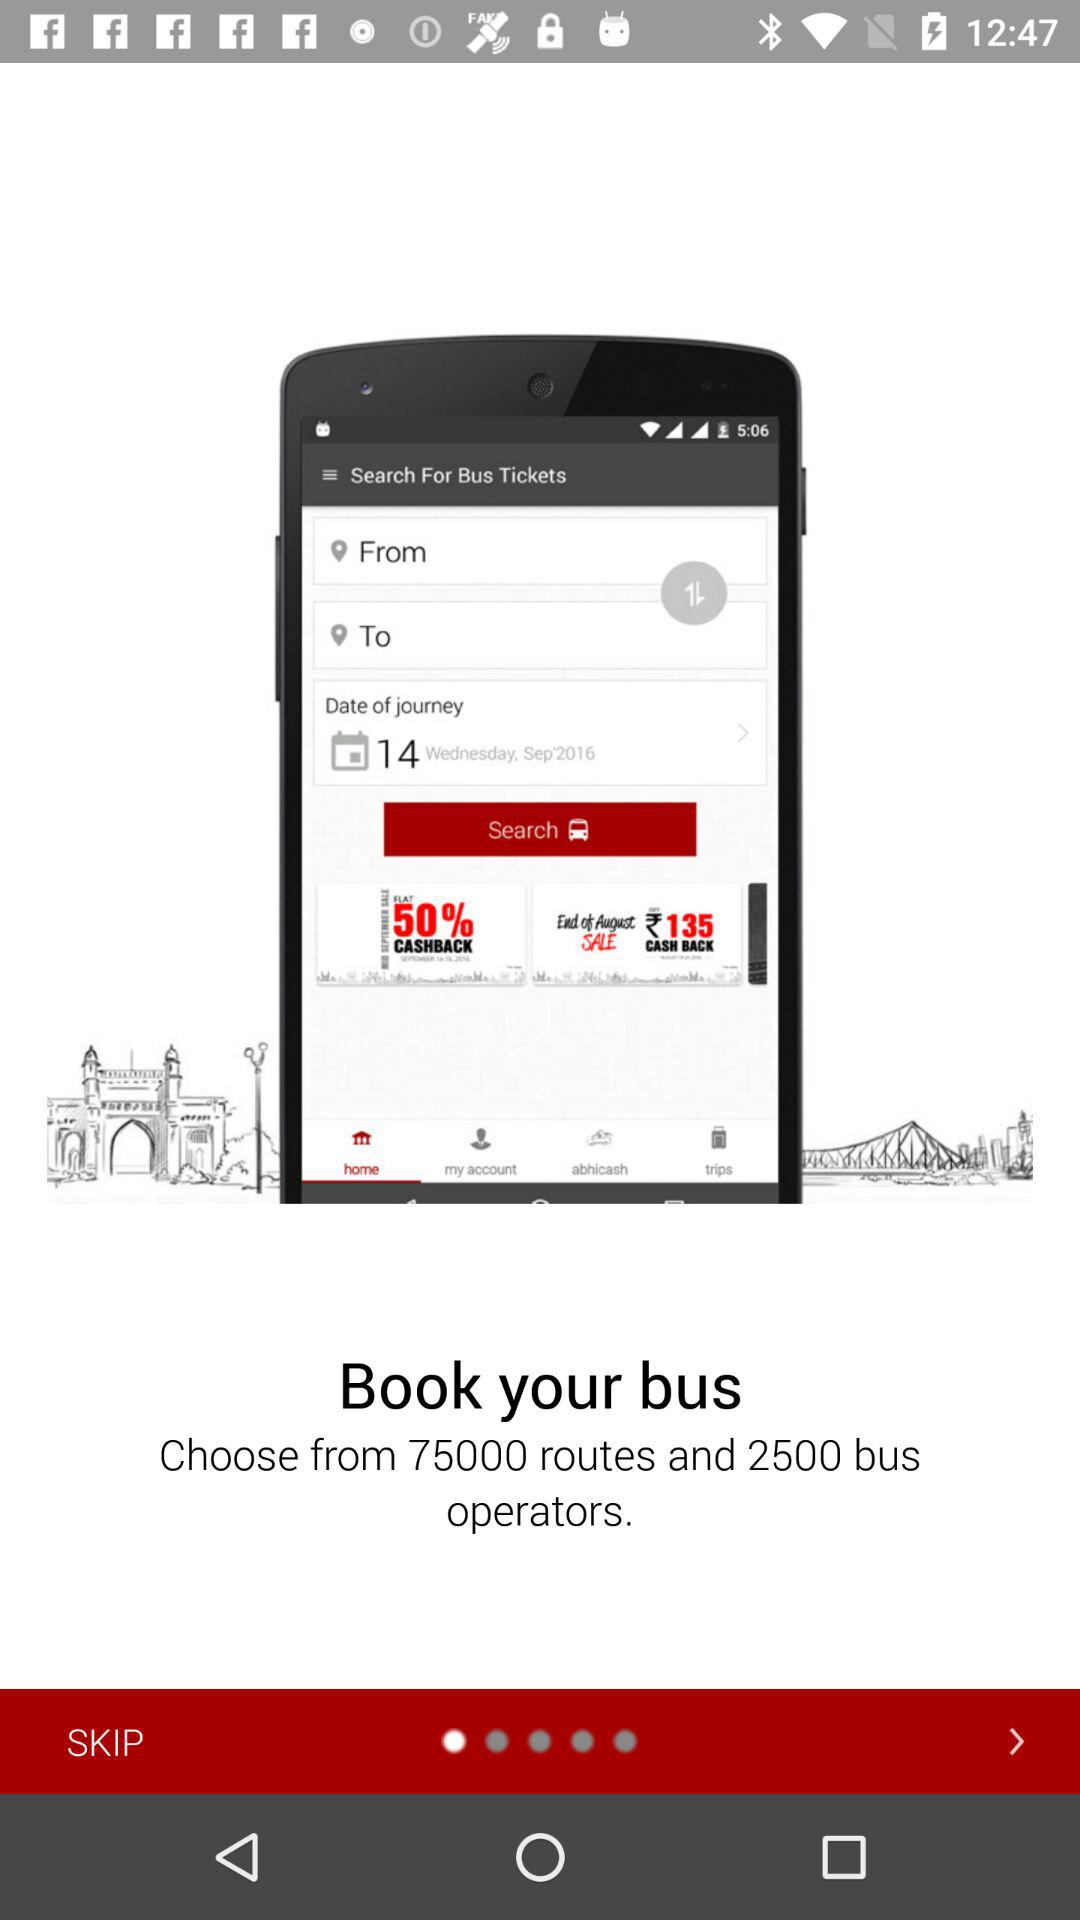How many routes are available? There are 75,000 routes available. 